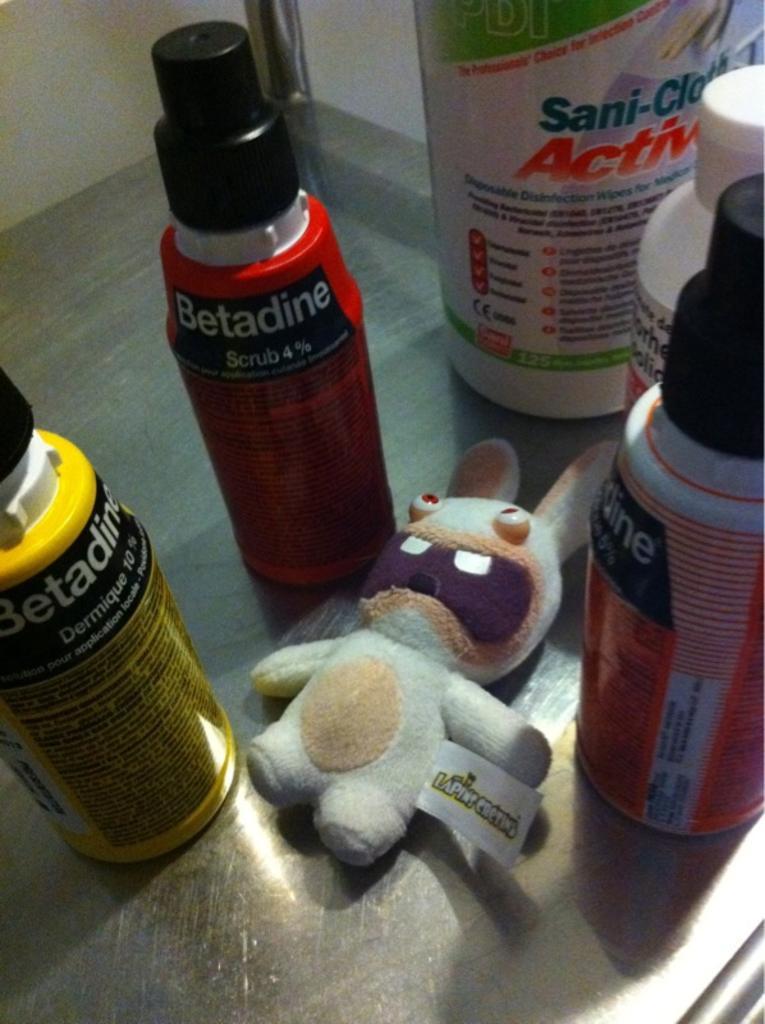In one or two sentences, can you explain what this image depicts? In this picture we can see a toy and bottles around it and this are some chemical bottles and placed on a floor. 